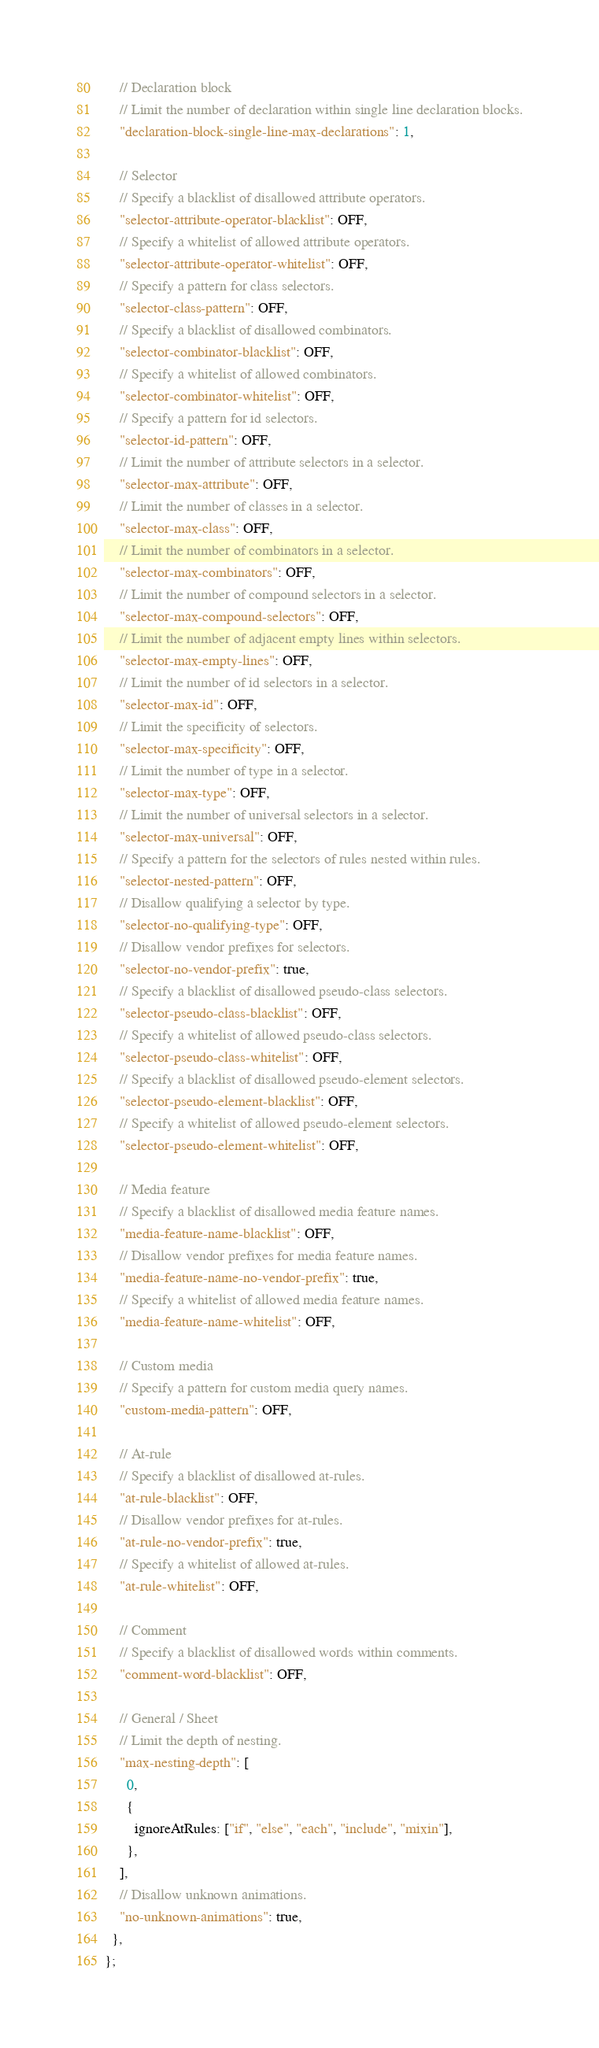Convert code to text. <code><loc_0><loc_0><loc_500><loc_500><_JavaScript_>
    // Declaration block
    // Limit the number of declaration within single line declaration blocks.
    "declaration-block-single-line-max-declarations": 1,

    // Selector
    // Specify a blacklist of disallowed attribute operators.
    "selector-attribute-operator-blacklist": OFF,
    // Specify a whitelist of allowed attribute operators.
    "selector-attribute-operator-whitelist": OFF,
    // Specify a pattern for class selectors.
    "selector-class-pattern": OFF,
    // Specify a blacklist of disallowed combinators.
    "selector-combinator-blacklist": OFF,
    // Specify a whitelist of allowed combinators.
    "selector-combinator-whitelist": OFF,
    // Specify a pattern for id selectors.
    "selector-id-pattern": OFF,
    // Limit the number of attribute selectors in a selector.
    "selector-max-attribute": OFF,
    // Limit the number of classes in a selector.
    "selector-max-class": OFF,
    // Limit the number of combinators in a selector.
    "selector-max-combinators": OFF,
    // Limit the number of compound selectors in a selector.
    "selector-max-compound-selectors": OFF,
    // Limit the number of adjacent empty lines within selectors.
    "selector-max-empty-lines": OFF,
    // Limit the number of id selectors in a selector.
    "selector-max-id": OFF,
    // Limit the specificity of selectors.
    "selector-max-specificity": OFF,
    // Limit the number of type in a selector.
    "selector-max-type": OFF,
    // Limit the number of universal selectors in a selector.
    "selector-max-universal": OFF,
    // Specify a pattern for the selectors of rules nested within rules.
    "selector-nested-pattern": OFF,
    // Disallow qualifying a selector by type.
    "selector-no-qualifying-type": OFF,
    // Disallow vendor prefixes for selectors.
    "selector-no-vendor-prefix": true,
    // Specify a blacklist of disallowed pseudo-class selectors.
    "selector-pseudo-class-blacklist": OFF,
    // Specify a whitelist of allowed pseudo-class selectors.
    "selector-pseudo-class-whitelist": OFF,
    // Specify a blacklist of disallowed pseudo-element selectors.
    "selector-pseudo-element-blacklist": OFF,
    // Specify a whitelist of allowed pseudo-element selectors.
    "selector-pseudo-element-whitelist": OFF,

    // Media feature
    // Specify a blacklist of disallowed media feature names.
    "media-feature-name-blacklist": OFF,
    // Disallow vendor prefixes for media feature names.
    "media-feature-name-no-vendor-prefix": true,
    // Specify a whitelist of allowed media feature names.
    "media-feature-name-whitelist": OFF,

    // Custom media
    // Specify a pattern for custom media query names.
    "custom-media-pattern": OFF,

    // At-rule
    // Specify a blacklist of disallowed at-rules.
    "at-rule-blacklist": OFF,
    // Disallow vendor prefixes for at-rules.
    "at-rule-no-vendor-prefix": true,
    // Specify a whitelist of allowed at-rules.
    "at-rule-whitelist": OFF,

    // Comment
    // Specify a blacklist of disallowed words within comments.
    "comment-word-blacklist": OFF,

    // General / Sheet
    // Limit the depth of nesting.
    "max-nesting-depth": [
      0,
      {
        ignoreAtRules: ["if", "else", "each", "include", "mixin"],
      },
    ],
    // Disallow unknown animations.
    "no-unknown-animations": true,
  },
};
</code> 